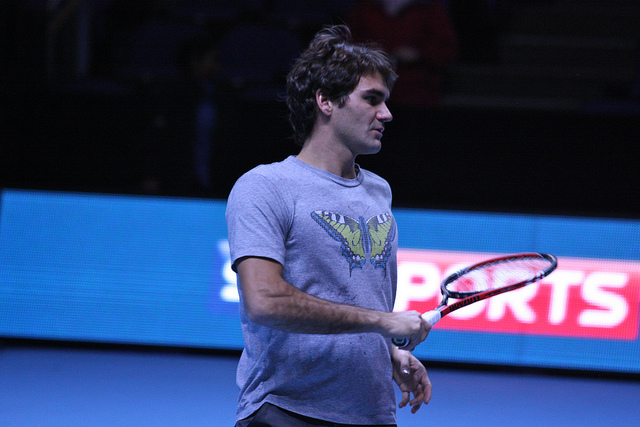Please extract the text content from this image. SPORTS 